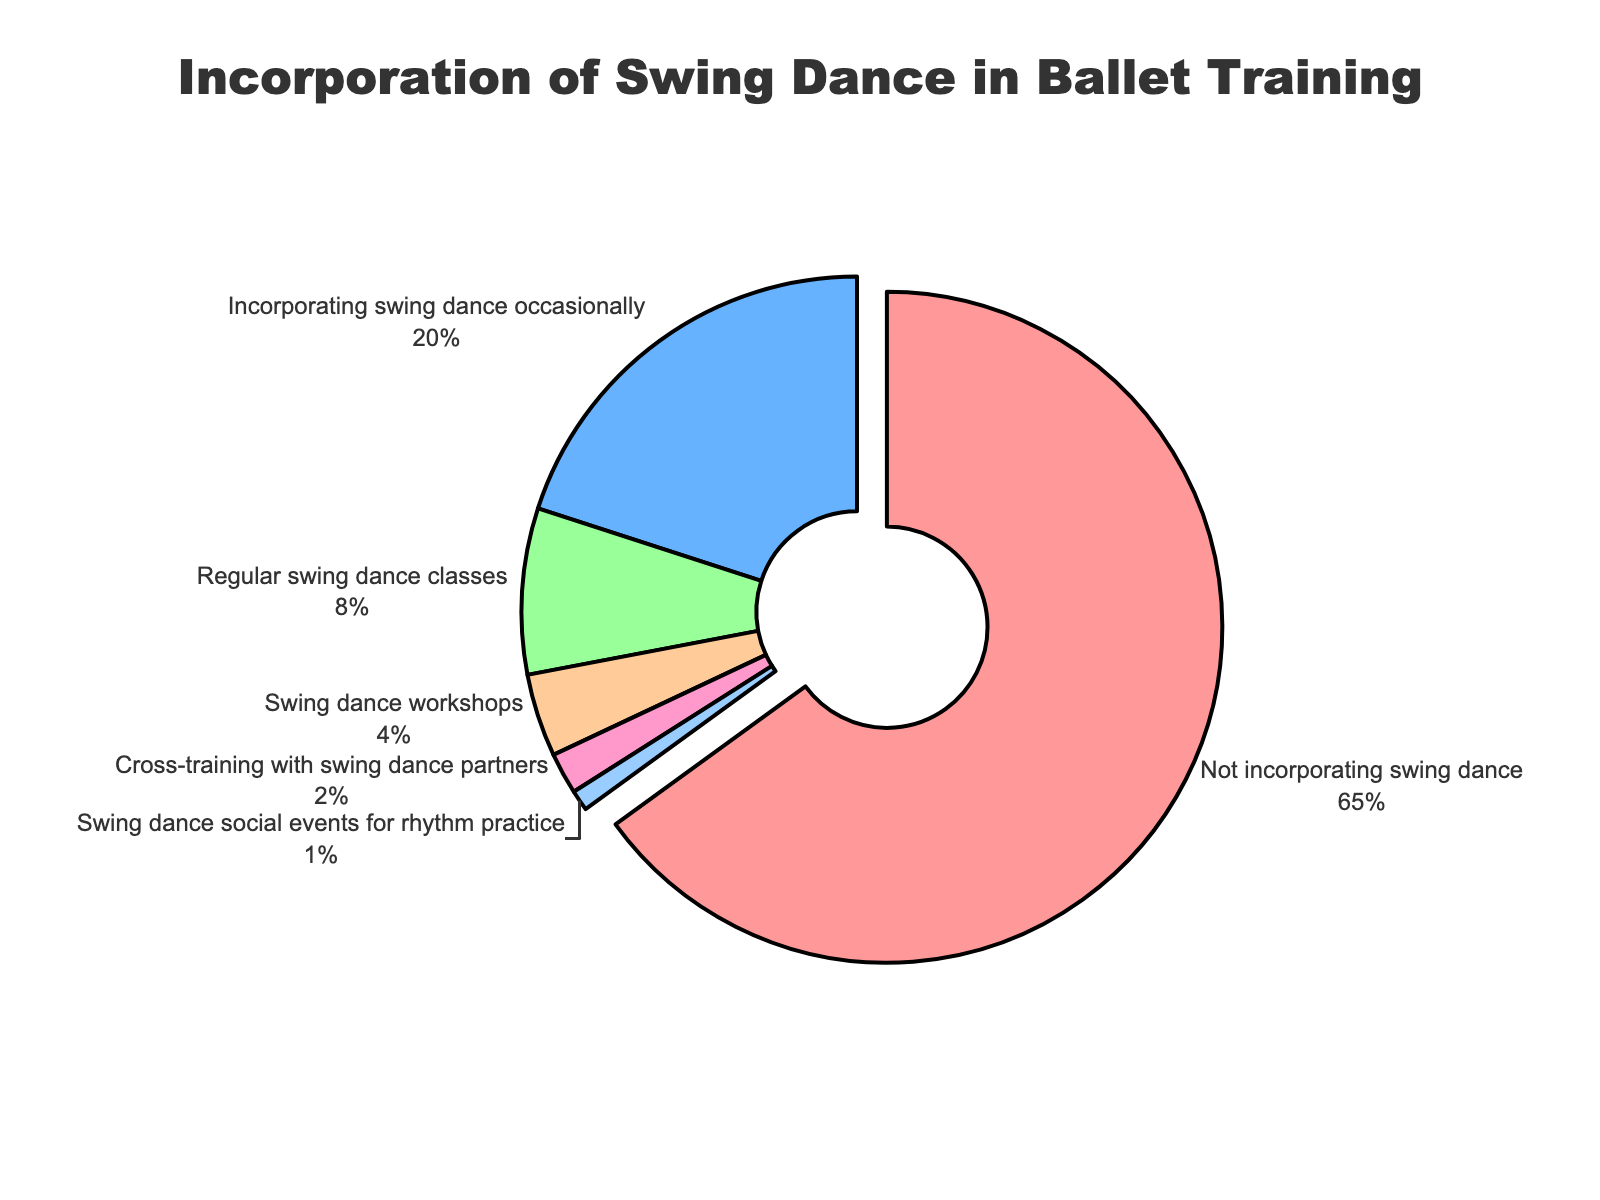What percentage of ballet dancers regularly take swing dance classes? Look at the pie chart segment labeled "Regular swing dance classes" and find the percentage value.
Answer: 8% Which category has the highest representation? Identify the largest segment in the pie chart. The segment "Not incorporating swing dance" is visually the largest.
Answer: Not incorporating swing dance How many ballet dancers incorporate swing dance occasionally compared to those who attend swing dance workshops? Find the percentages for "Incorporating swing dance occasionally" (20%) and "Swing dance workshops" (4%), and compare them. 20% is larger than 4%.
Answer: Incorporating swing dance occasionally What is the total percentage of ballet dancers involved in any form of swing dance activity? Sum all the percentages except for "Not incorporating swing dance": 20% + 8% + 4% + 2% + 1% = 35%.
Answer: 35% Which categories of swing dance incorporation have percentages less than 5%? Identify the segments that have percentages less than 5%: "Swing dance workshops" (4%), "Cross-training with swing dance partners" (2%), "Swing dance social events for rhythm practice" (1%).
Answer: Swing dance workshops, Cross-training with swing dance partners, Swing dance social events for rhythm practice How much larger is the "Not incorporating swing dance" category compared to the "Incorporating swing dance occasionally" category? Subtract the percentage of "Incorporating swing dance occasionally" (20%) from "Not incorporating swing dance" (65%): 65% - 20% = 45%.
Answer: 45% What color represents the "Cross-training with swing dance partners" category in the chart? Identify the color of the segment labeled "Cross-training with swing dance partners". It is marked in a purple-pink shade.
Answer: Purple-pink What portion of the pie chart is dedicated to "Swing dance social events for rhythm practice"? Look at the segment labeled "Swing dance social events for rhythm practice" and find the percentage value.
Answer: 1% If you combine the percentages of "Swing dance workshops" and "Cross-training with swing dance partners," how does their total compare to the "Regular swing dance classes" percentage? Sum the percentages of "Swing dance workshops" (4%) and "Cross-training with swing dance partners" (2%): 4% + 2% = 6%. Compare this to "Regular swing dance classes" (8%). 6% is less than 8%.
Answer: Less than What percentage of the pie chart is dedicated to categories that have something to do with swing dance social events or partners? Combine the percentages of "Cross-training with swing dance partners" (2%) and "Swing dance social events for rhythm practice" (1%): 2% + 1% = 3%.
Answer: 3% 